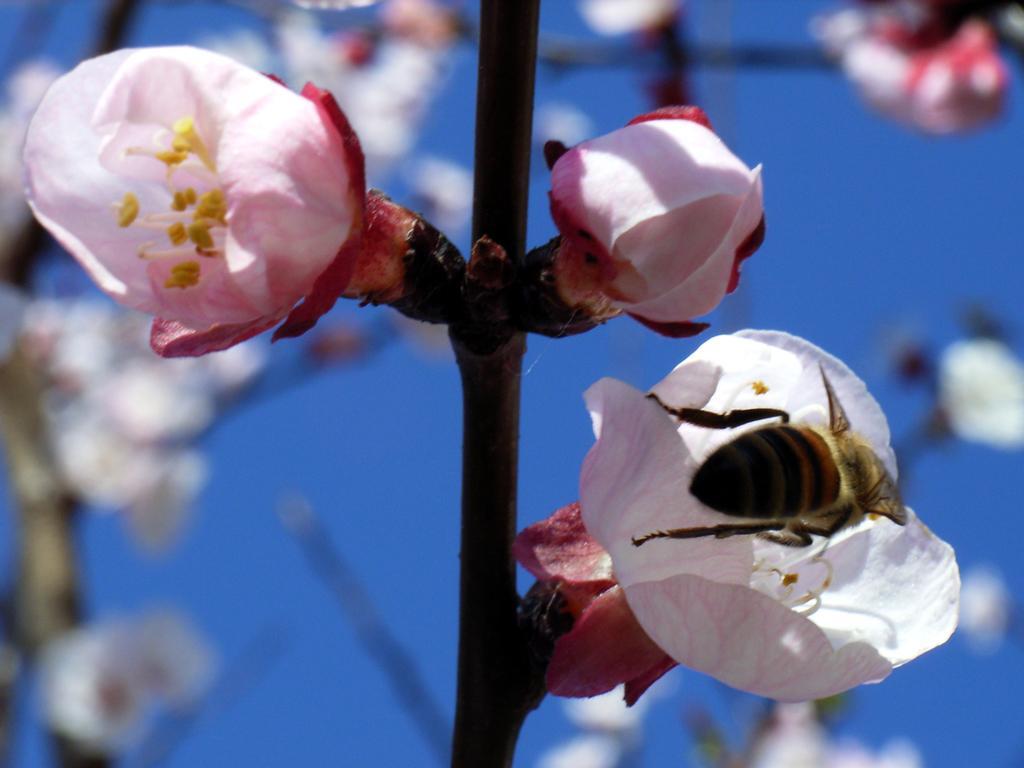In one or two sentences, can you explain what this image depicts? In this image I can see few flowers which are pink and yellow in color to a plant and an insect which is yellow and black in color on a flower. In the background I can see few plants and the sky. 